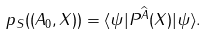<formula> <loc_0><loc_0><loc_500><loc_500>p _ { S } ( ( A _ { 0 } , X ) ) = \langle \psi | P ^ { \widehat { A } } ( X ) | \psi \rangle .</formula> 